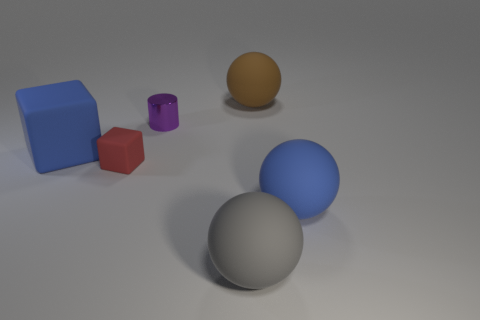Add 2 blue things. How many objects exist? 8 Subtract all big brown matte balls. How many balls are left? 2 Subtract all cylinders. How many objects are left? 5 Subtract all cyan balls. Subtract all brown cylinders. How many balls are left? 3 Subtract all big brown things. Subtract all brown rubber spheres. How many objects are left? 4 Add 4 tiny red matte things. How many tiny red matte things are left? 5 Add 4 big brown objects. How many big brown objects exist? 5 Subtract 0 gray cylinders. How many objects are left? 6 